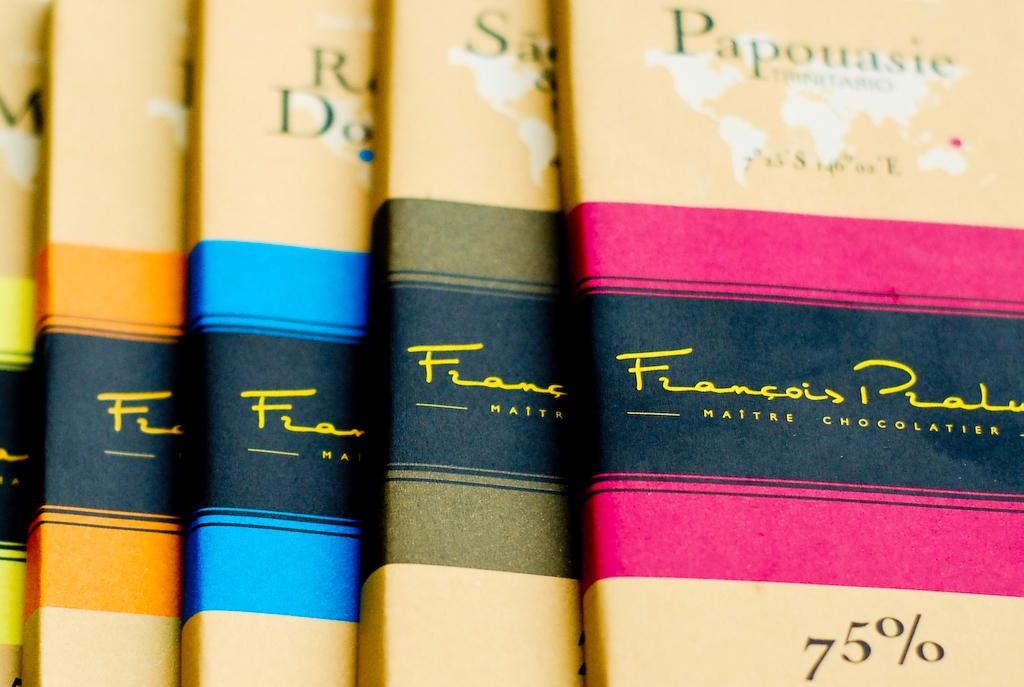What percent is the chocolate bar?
Provide a short and direct response. 75. Is this maitre chocolatier?
Ensure brevity in your answer.  Yes. 